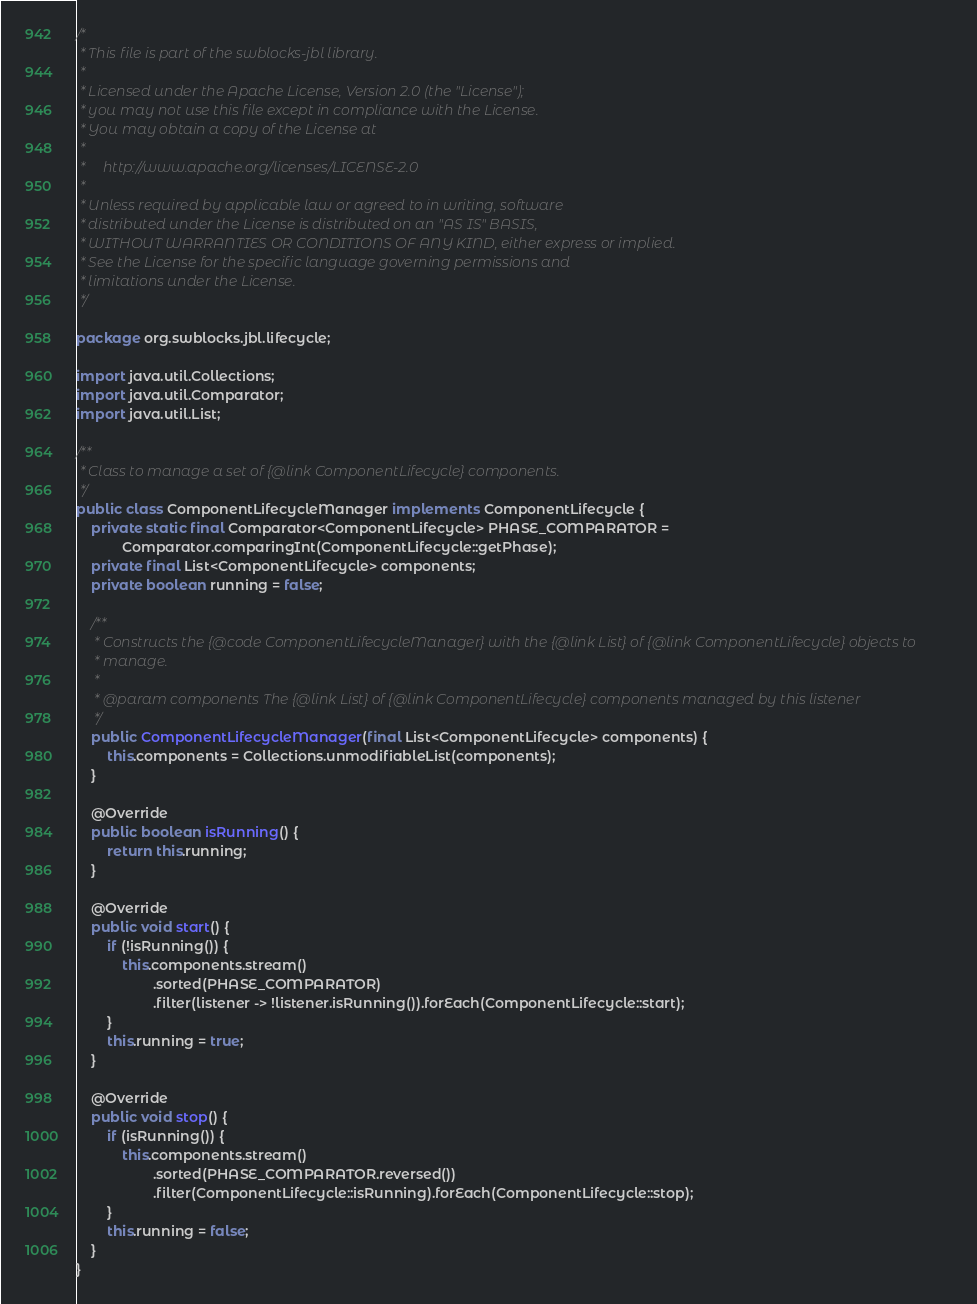<code> <loc_0><loc_0><loc_500><loc_500><_Java_>/*
 * This file is part of the swblocks-jbl library.
 *
 * Licensed under the Apache License, Version 2.0 (the "License");
 * you may not use this file except in compliance with the License.
 * You may obtain a copy of the License at
 *
 *     http://www.apache.org/licenses/LICENSE-2.0
 *
 * Unless required by applicable law or agreed to in writing, software
 * distributed under the License is distributed on an "AS IS" BASIS,
 * WITHOUT WARRANTIES OR CONDITIONS OF ANY KIND, either express or implied.
 * See the License for the specific language governing permissions and
 * limitations under the License.
 */

package org.swblocks.jbl.lifecycle;

import java.util.Collections;
import java.util.Comparator;
import java.util.List;

/**
 * Class to manage a set of {@link ComponentLifecycle} components.
 */
public class ComponentLifecycleManager implements ComponentLifecycle {
    private static final Comparator<ComponentLifecycle> PHASE_COMPARATOR =
            Comparator.comparingInt(ComponentLifecycle::getPhase);
    private final List<ComponentLifecycle> components;
    private boolean running = false;

    /**
     * Constructs the {@code ComponentLifecycleManager} with the {@link List} of {@link ComponentLifecycle} objects to
     * manage.
     *
     * @param components The {@link List} of {@link ComponentLifecycle} components managed by this listener
     */
    public ComponentLifecycleManager(final List<ComponentLifecycle> components) {
        this.components = Collections.unmodifiableList(components);
    }

    @Override
    public boolean isRunning() {
        return this.running;
    }

    @Override
    public void start() {
        if (!isRunning()) {
            this.components.stream()
                    .sorted(PHASE_COMPARATOR)
                    .filter(listener -> !listener.isRunning()).forEach(ComponentLifecycle::start);
        }
        this.running = true;
    }

    @Override
    public void stop() {
        if (isRunning()) {
            this.components.stream()
                    .sorted(PHASE_COMPARATOR.reversed())
                    .filter(ComponentLifecycle::isRunning).forEach(ComponentLifecycle::stop);
        }
        this.running = false;
    }
}
</code> 